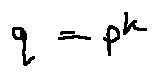Convert formula to latex. <formula><loc_0><loc_0><loc_500><loc_500>q = p ^ { k }</formula> 